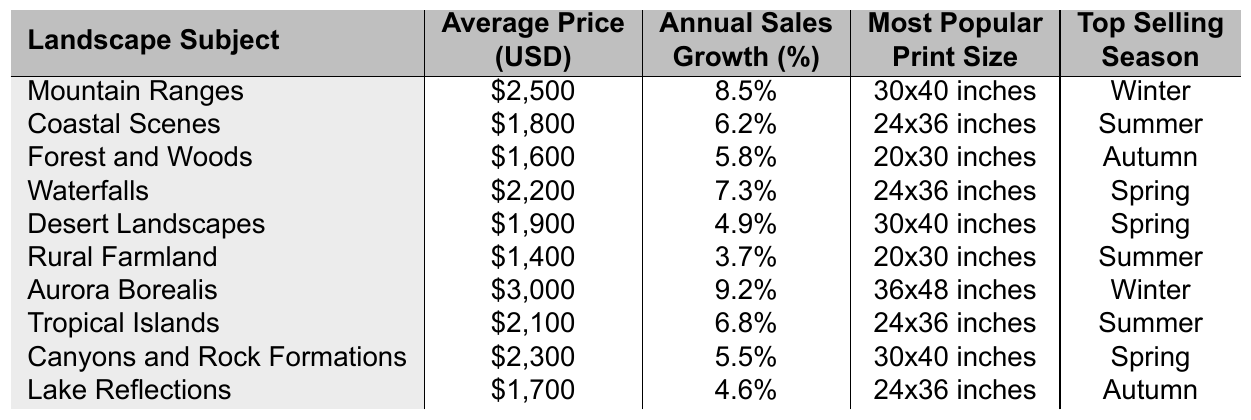What is the average price of "Mountain Ranges"? The table states that the average price of "Mountain Ranges" is $2,500.
Answer: $2,500 Which landscape subject has the highest annual sales growth? According to the table, "Aurora Borealis" has the highest sales growth at 9.2%.
Answer: 9.2% What is the most popular print size for "Waterfalls"? The data indicates that the most popular print size for "Waterfalls" is 24x36 inches.
Answer: 24x36 inches True or False: "Rural Farmland" has higher average price than "Forest and Woods." By comparing the average prices, "Rural Farmland" ($1,400) is less than "Forest and Woods" ($1,600), so the statement is false.
Answer: False Which subjects are most popular during the Summer season? The subjects listed for Summer in the table are "Coastal Scenes," "Rural Farmland," and "Tropical Islands."
Answer: Coastal Scenes, Rural Farmland, Tropical Islands What is the total annual sales growth for "Mountain Ranges" and "Aurora Borealis"? Adding the annual sales growth of both subjects: 8.5% (Mountain Ranges) + 9.2% (Aurora Borealis) = 17.7%.
Answer: 17.7% What print size is most popular for all four subjects that are in the Spring season? The print sizes for the Spring season—"Waterfalls," "Desert Landscapes," and "Canyons and Rock Formations"—are 24x36 inches and 30x40 inches, with the most common being 24x36 inches for two of the three subjects.
Answer: 24x36 inches Which landscape subject has the lowest average price and what is it? The lowest average price listed in the table is for "Rural Farmland," priced at $1,400.
Answer: Rural Farmland, $1,400 If you combine the average prices of the top three subjects by sales growth, what is the total? The top three subjects by sales growth are "Aurora Borealis" ($3,000), "Mountain Ranges" ($2,500), and "Waterfalls" ($2,200). Adding these together: $3,000 + $2,500 + $2,200 = $7,700.
Answer: $7,700 What is the most expensive landscape subject and its price? The most expensive landscape subject is "Aurora Borealis," priced at $3,000 as stated in the table.
Answer: Aurora Borealis, $3,000 